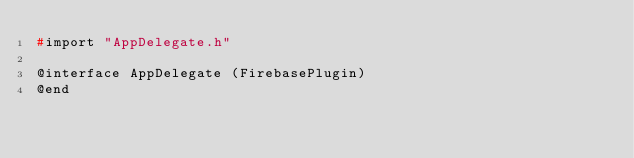<code> <loc_0><loc_0><loc_500><loc_500><_C_>#import "AppDelegate.h"

@interface AppDelegate (FirebasePlugin)
@end
</code> 